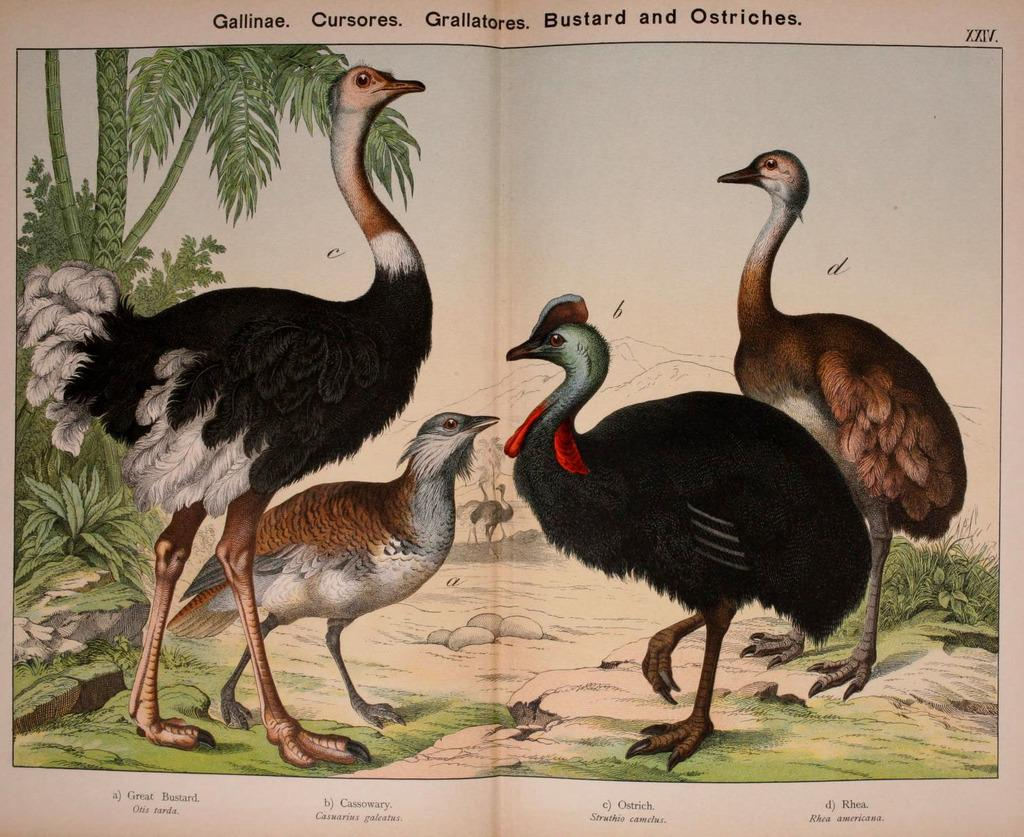What is the main subject of the paper in the image? The paper contains images of birds. What colors are the birds depicted in? The birds are in black, red, and brown colors. What else can be seen in the image besides the paper? There are plants visible in the image. What information is written on the paper? Names are written on the paper. Can you tell me how many frogs are quivering in the image? There are no frogs present in the image, and therefore no quivering can be observed. 